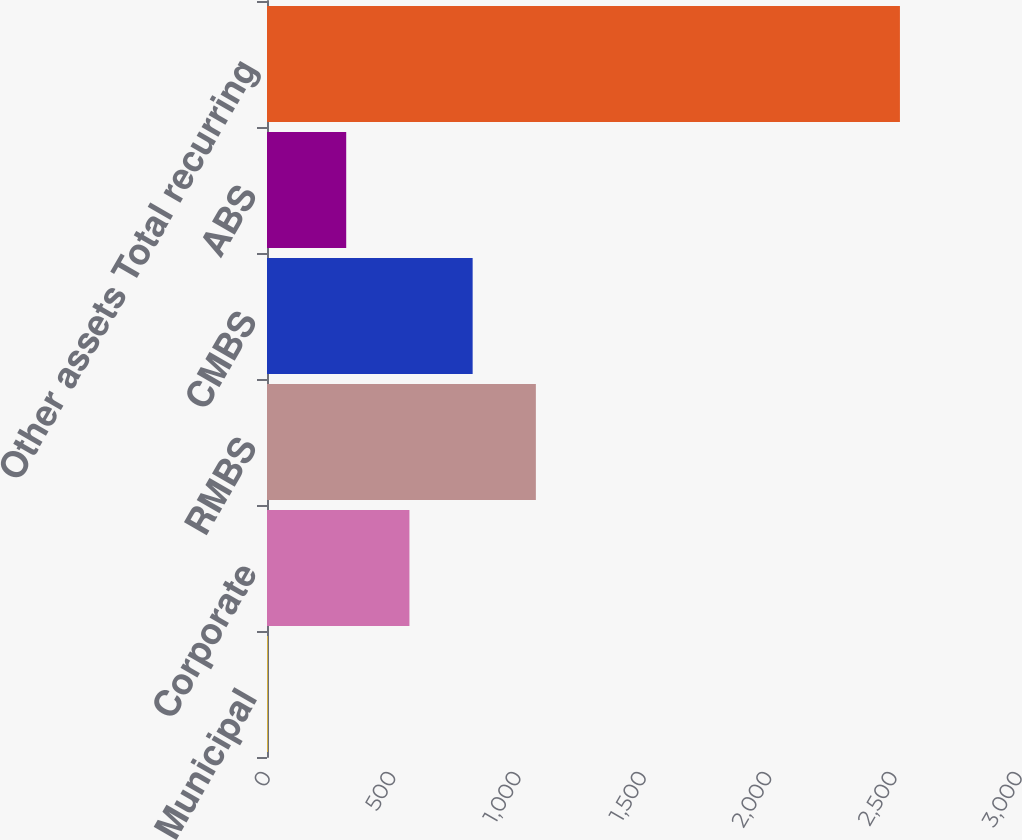<chart> <loc_0><loc_0><loc_500><loc_500><bar_chart><fcel>Municipal<fcel>Corporate<fcel>RMBS<fcel>CMBS<fcel>ABS<fcel>Other assets Total recurring<nl><fcel>3<fcel>568.2<fcel>1072.6<fcel>820.4<fcel>316<fcel>2525<nl></chart> 